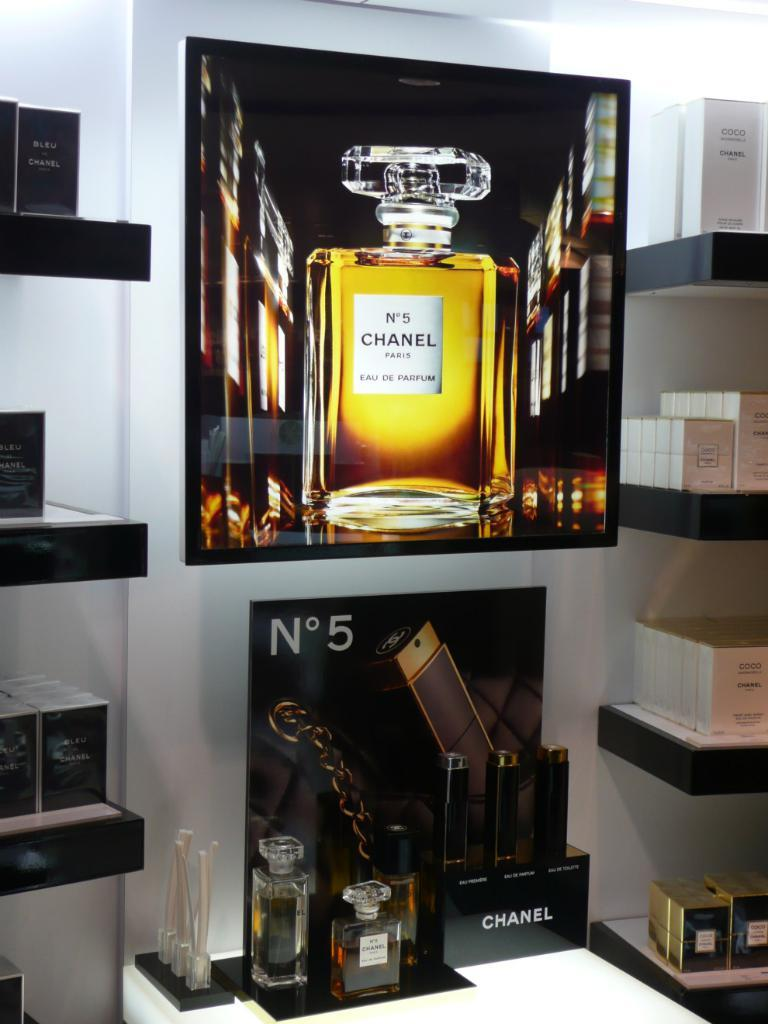<image>
Relay a brief, clear account of the picture shown. Display full of cologne including Chanel No 5. 